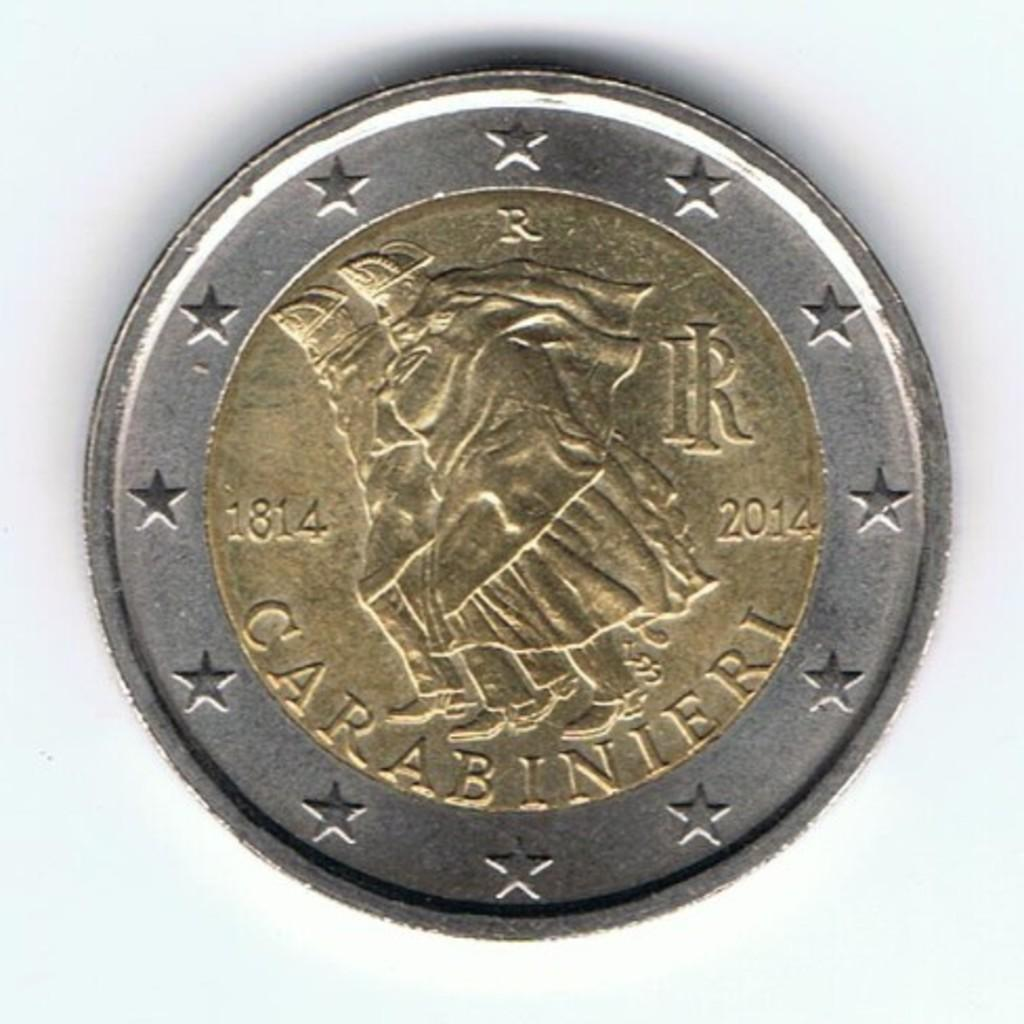<image>
Summarize the visual content of the image. A gold coin surrounded by silver says Carabinieri under the image of two men. 